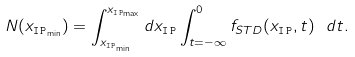<formula> <loc_0><loc_0><loc_500><loc_500>N ( x _ { { \tt I \, P } _ { \min } } ) = \int _ { x _ { { \tt I \, P } _ { \min } } } ^ { x _ { { \tt I \, P } _ { \max } } } d x _ { \tt I \, P } \int ^ { 0 } _ { t = - \infty } f _ { S T D } ( x _ { \tt I \, P } , t ) \ d t .</formula> 